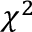Convert formula to latex. <formula><loc_0><loc_0><loc_500><loc_500>\chi ^ { 2 }</formula> 